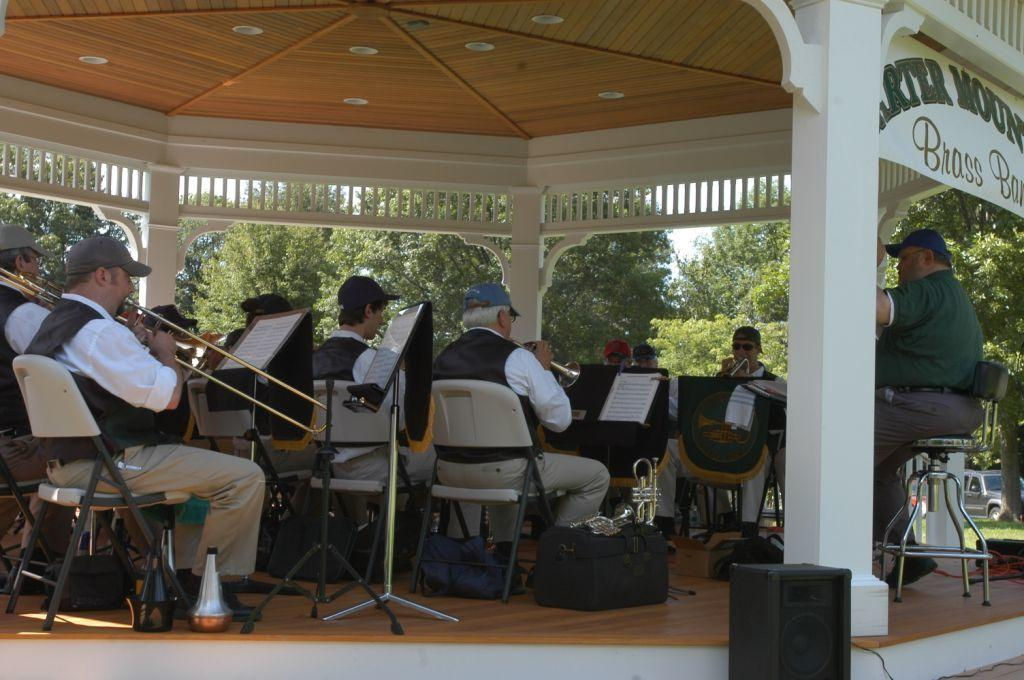What is happening in the image involving the group of people? The people in the image are playing musical instruments. How are the people positioned in the image? The people are sitting on chairs. What can be seen in the background of the image? There are trees, a pillar, and the sky visible in the background. Reasoning: Let'g: Let's think step by step in order to produce the conversation. We start by identifying the main subject in the image, which is the group of people. Then, we describe what they are doing, which is playing musical instruments. Next, we mention their positioning, which is sitting on chairs. Finally, we expand the conversation to include details about the background, such as the presence of trees, a pillar, and the sky. Absurd Question/Answer: Who is the creator of the crown visible in the image? There is no crown present in the image. What type of cloth is draped over the pillar in the image? There is no cloth draped over the pillar in the image. 